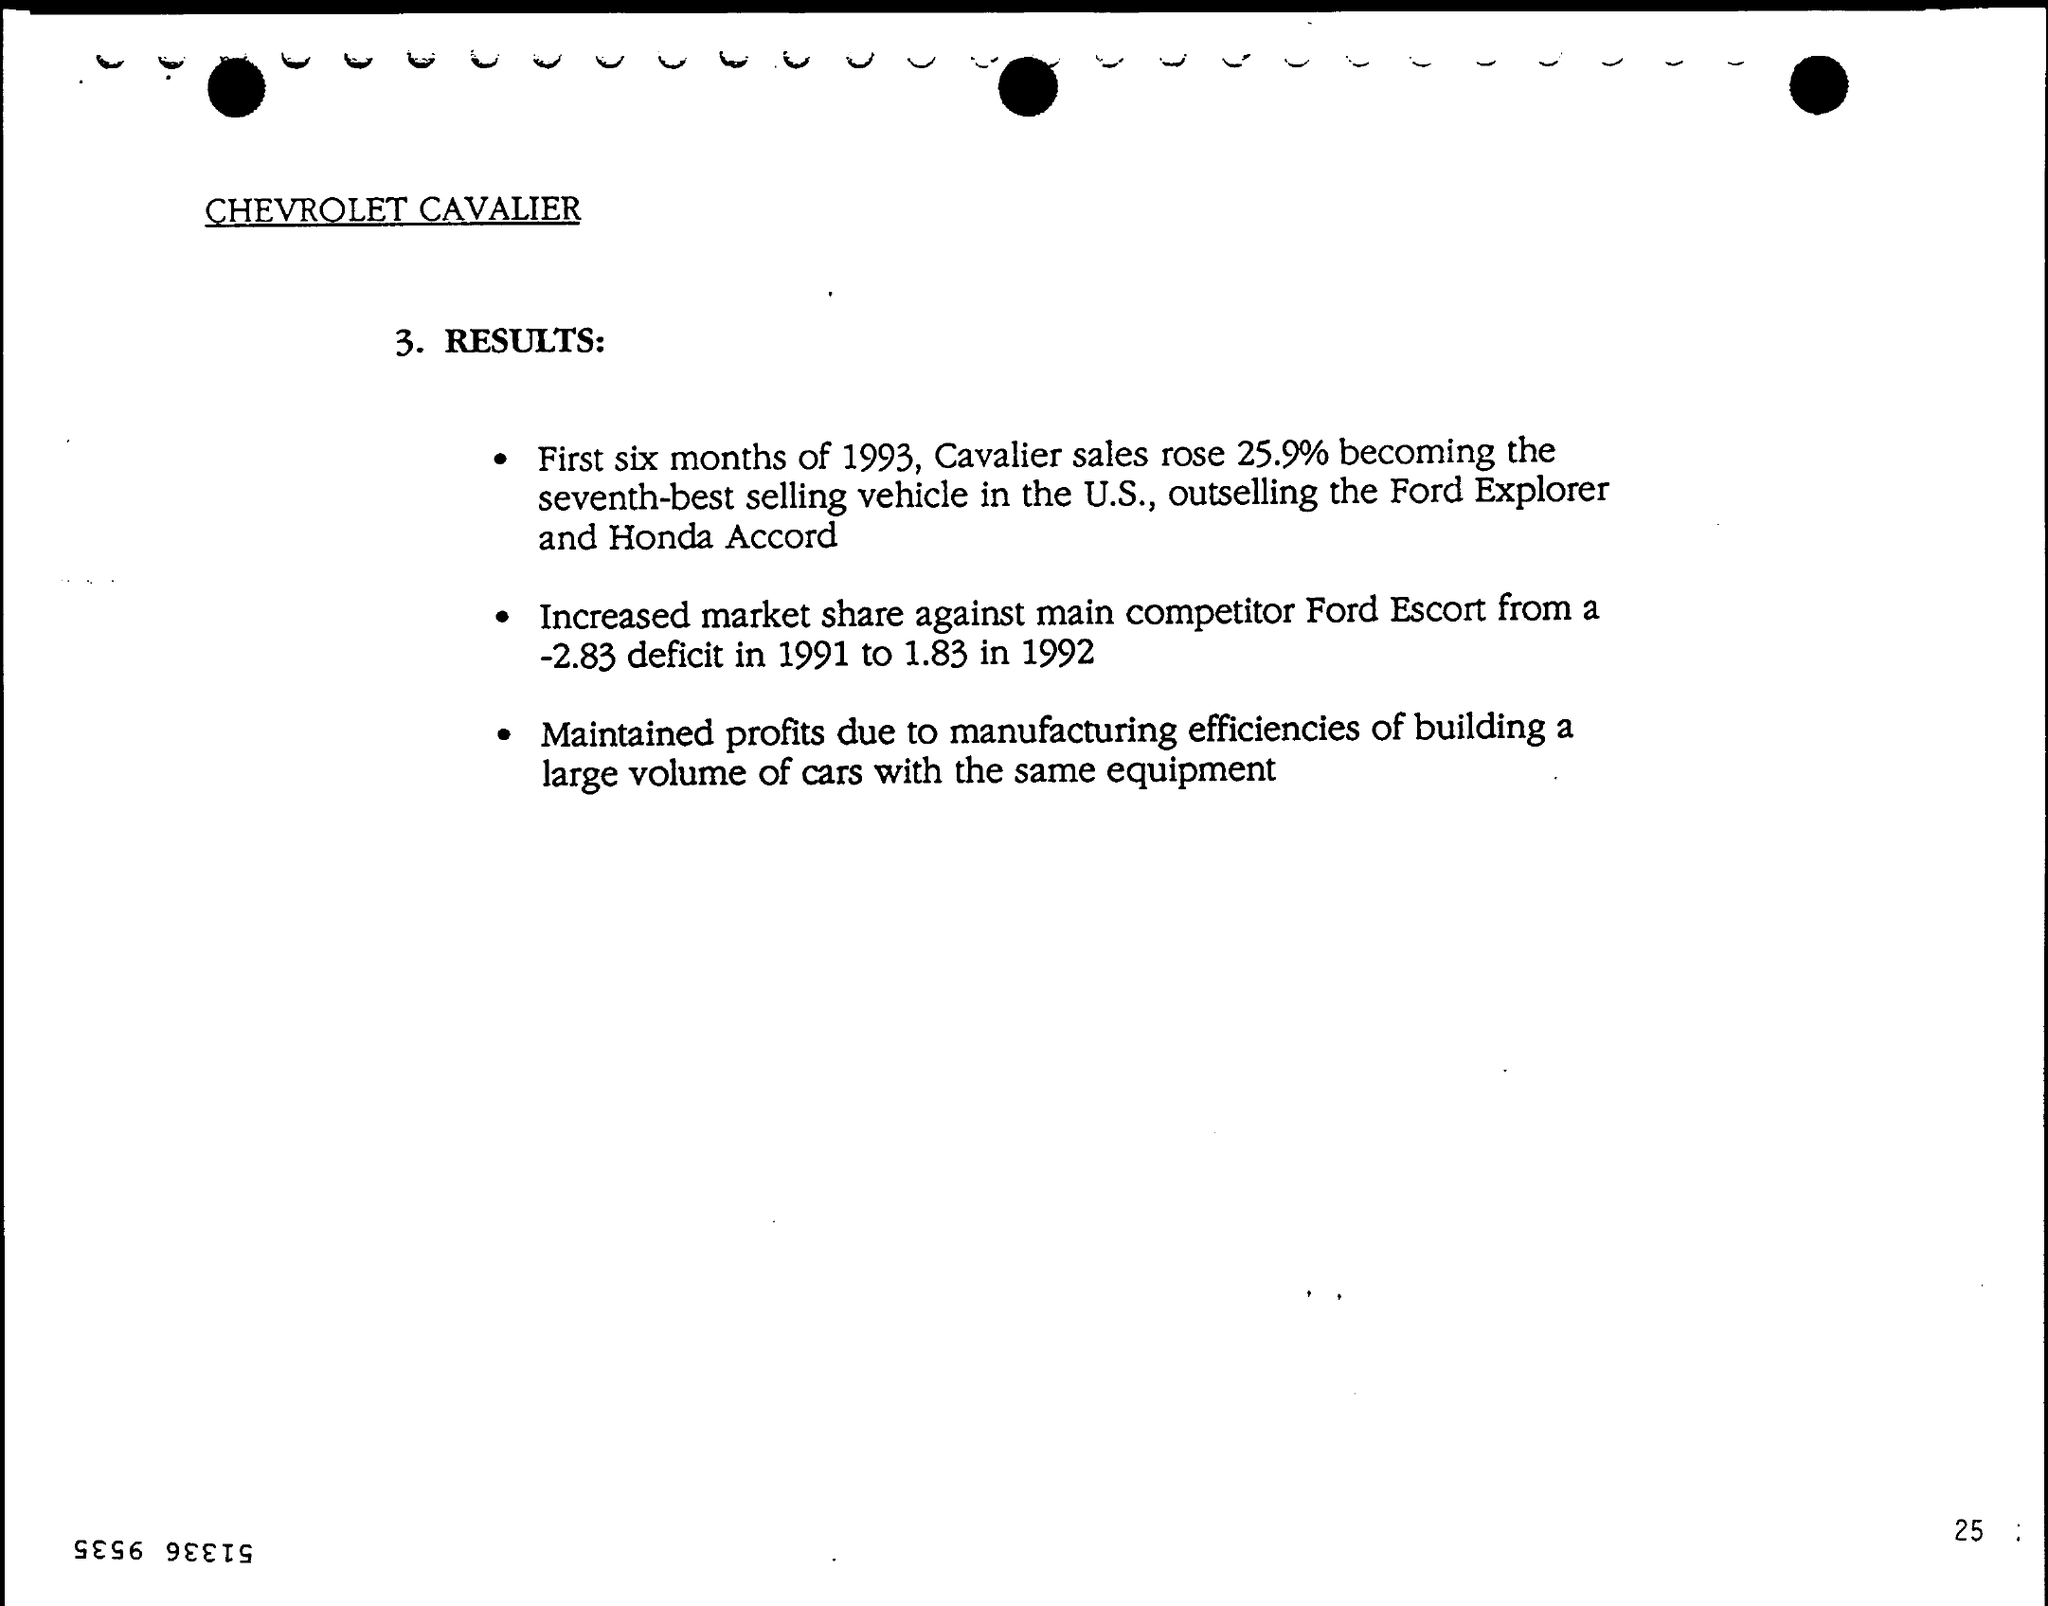Identify some key points in this picture. In the 1970s, the main competitor of the Ford Cavalier was the Ford Escort, which was a popular compact car that competed in the same market segment. The sales of Cavalier cars rose by 25.9% during the first six months of 1993. 